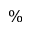Convert formula to latex. <formula><loc_0><loc_0><loc_500><loc_500>\%</formula> 